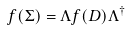<formula> <loc_0><loc_0><loc_500><loc_500>f ( \Sigma ) = \Lambda f ( D ) \Lambda ^ { \dagger }</formula> 